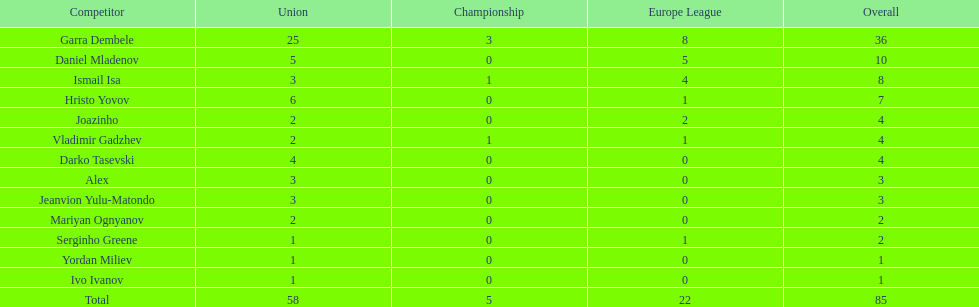Who scored the most goals for this team? Garra Dembele. 